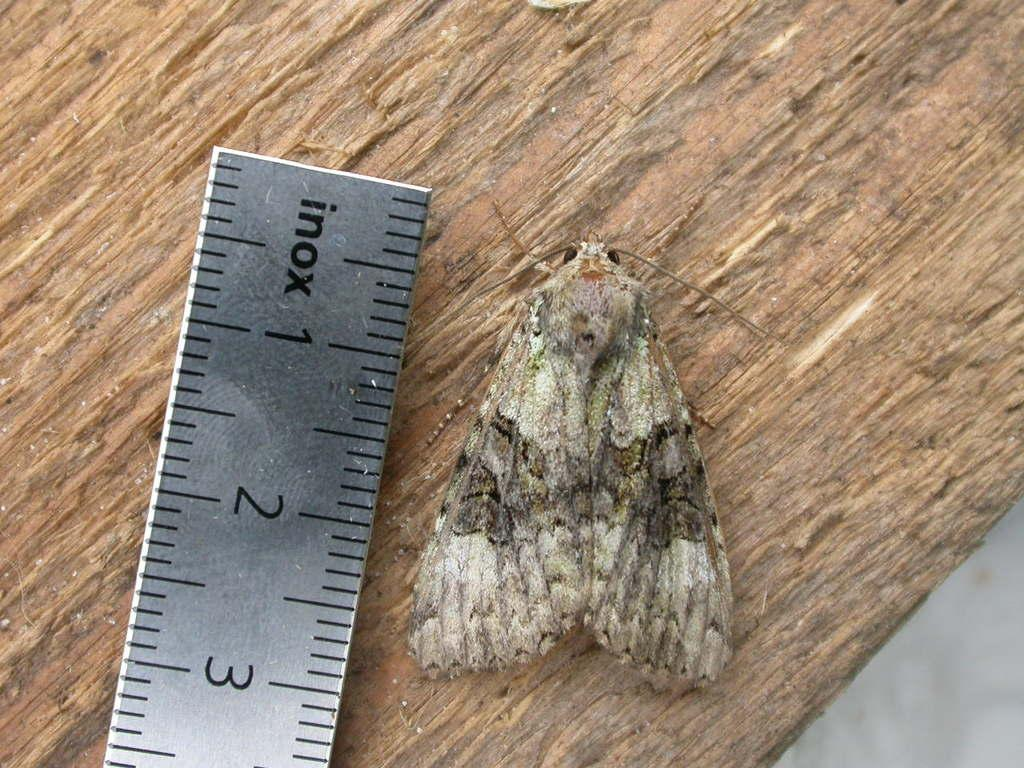<image>
Relay a brief, clear account of the picture shown. A moth that is being measured at 2 and 4/5 inches long. 